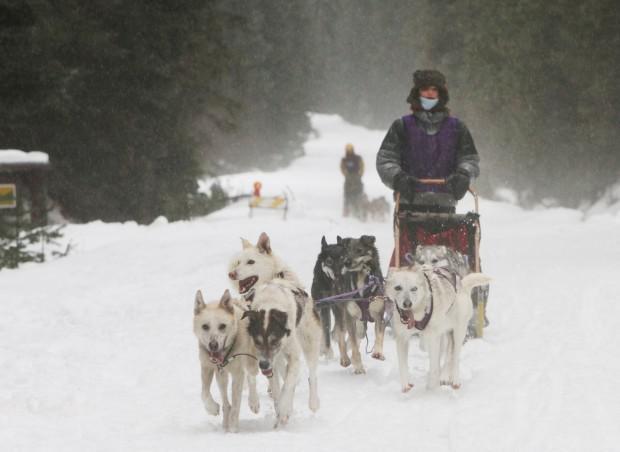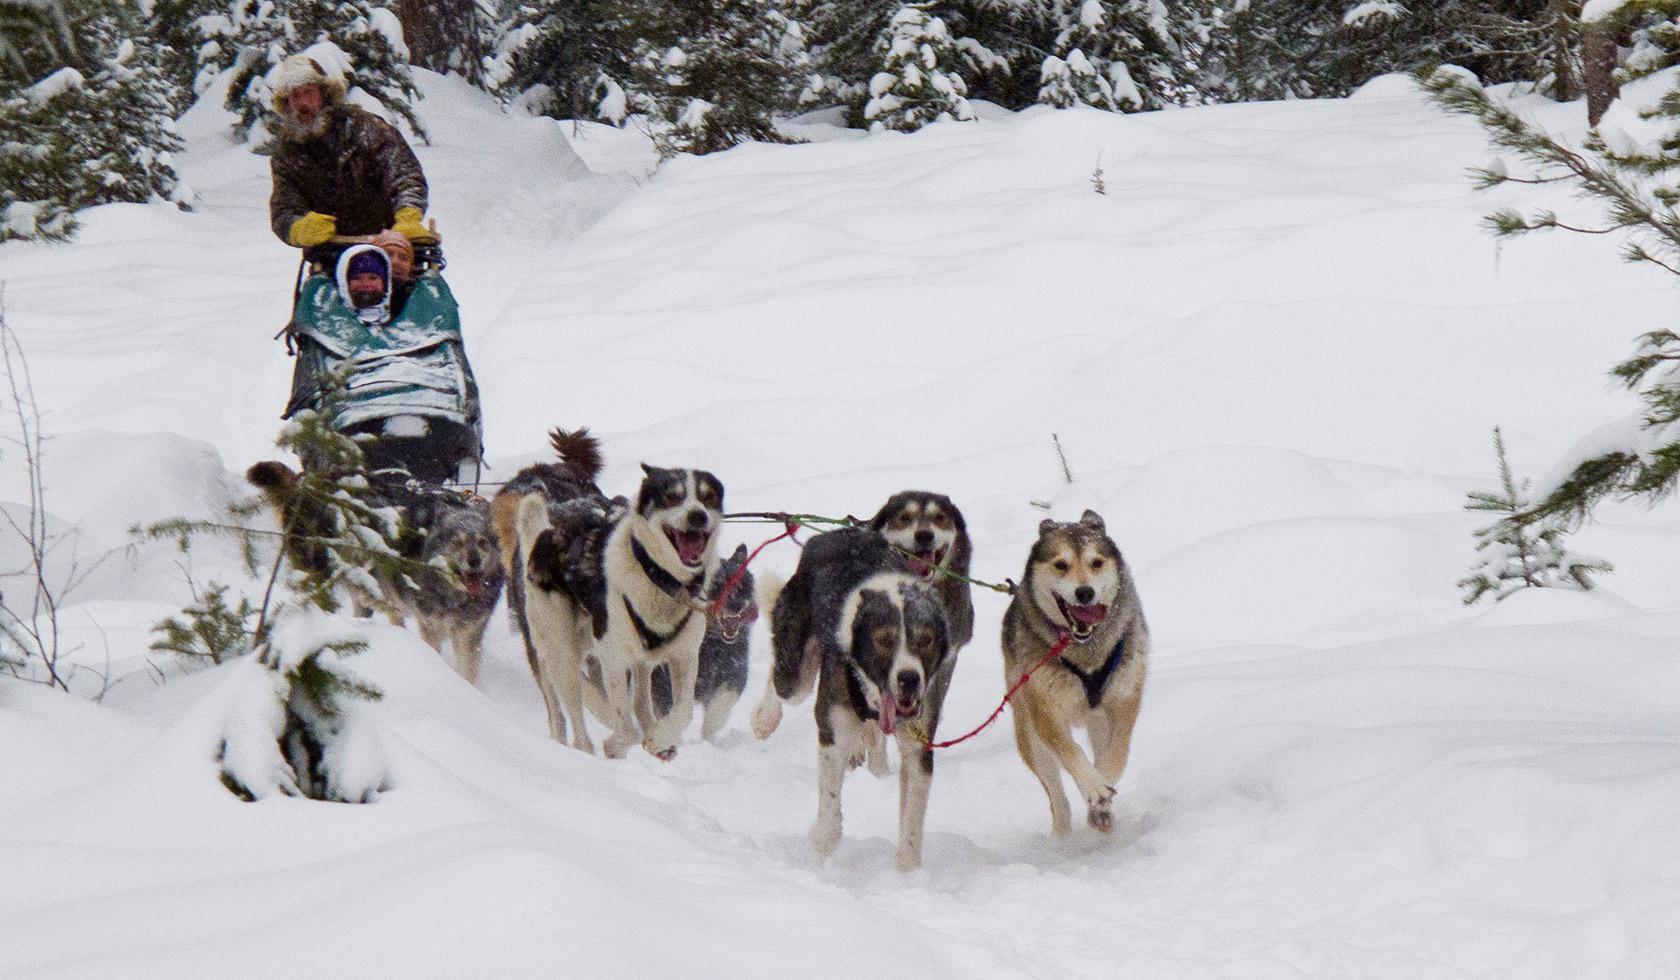The first image is the image on the left, the second image is the image on the right. For the images displayed, is the sentence "There are at least two sets of sled dogs pulling a bundled up human behind them." factually correct? Answer yes or no. Yes. The first image is the image on the left, the second image is the image on the right. Evaluate the accuracy of this statement regarding the images: "Left image shows a rider with an orange vest at the left of the picture.". Is it true? Answer yes or no. No. 